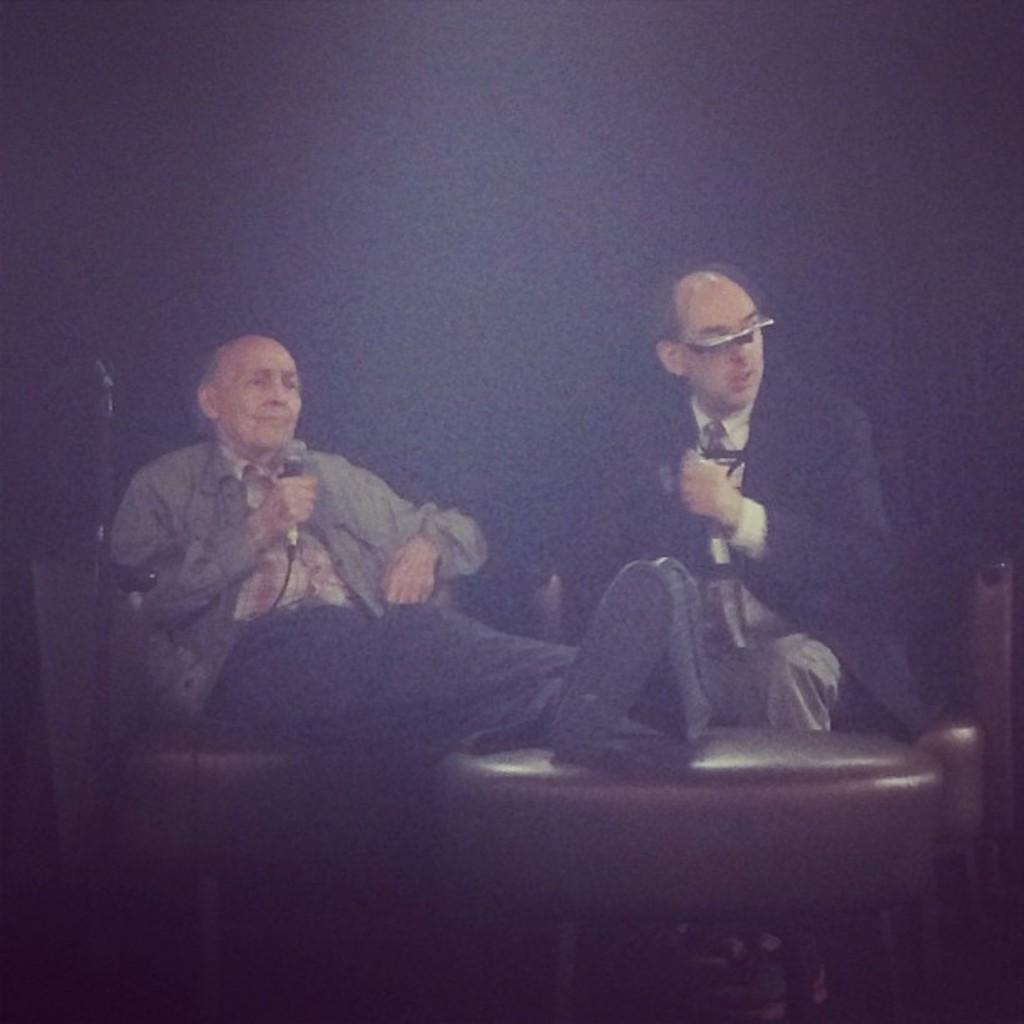How would you summarize this image in a sentence or two? On the left side, there is a person, holding a microphone, sitting and placing both hands on a table. On the right side, there is another person in a suit, speaking and sitting. And the background is dark in color. 